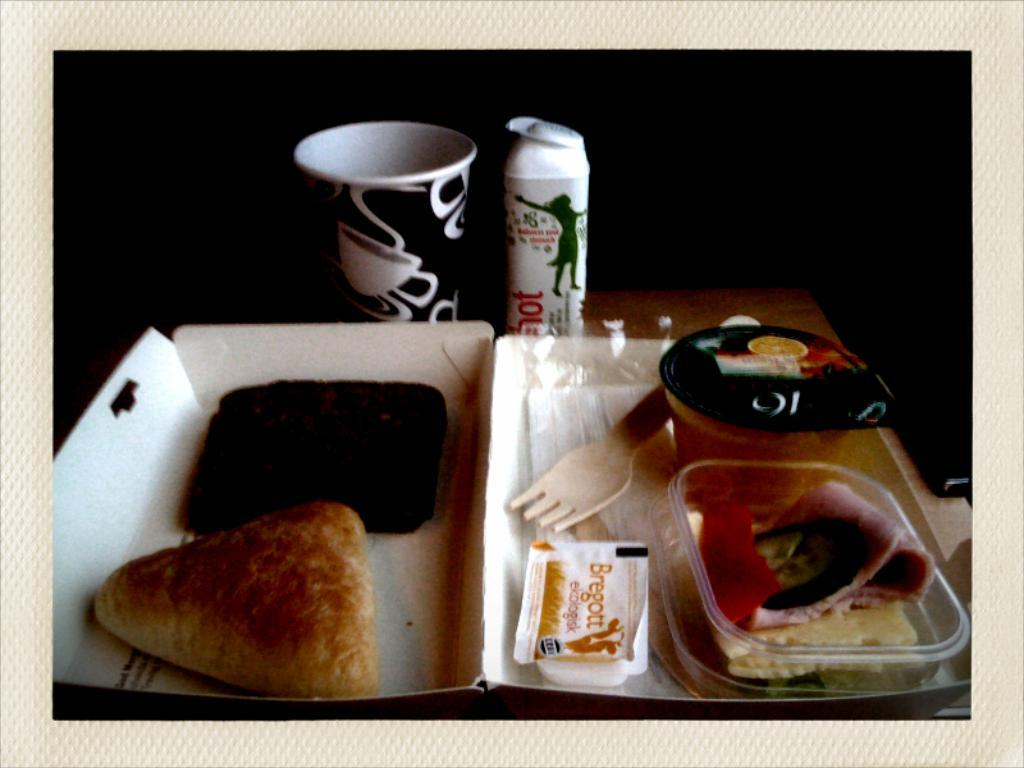What is the person holding in the image? The person is holding an umbrella in the image. What is the weather like in the image? It is raining in the image. What activity is the person doing while holding the umbrella? The person is walking in the rain. What type of bead is the person wearing around their neck in the image? There is no bead visible around the person's neck in the image. What decision did the person make before deciding to walk in the rain with an umbrella? The image does not provide information about any decisions made by the person. 